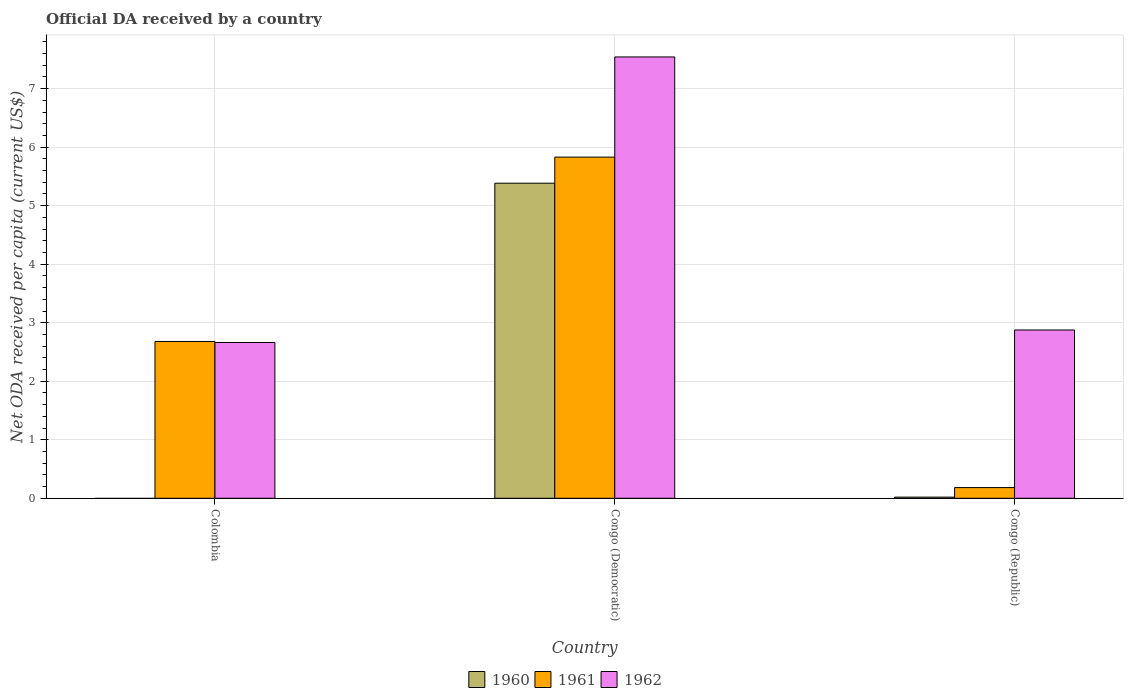How many different coloured bars are there?
Your response must be concise. 3. Are the number of bars per tick equal to the number of legend labels?
Provide a short and direct response. No. Are the number of bars on each tick of the X-axis equal?
Make the answer very short. No. How many bars are there on the 3rd tick from the right?
Make the answer very short. 2. What is the label of the 2nd group of bars from the left?
Ensure brevity in your answer.  Congo (Democratic). In how many cases, is the number of bars for a given country not equal to the number of legend labels?
Ensure brevity in your answer.  1. What is the ODA received in in 1962 in Congo (Democratic)?
Your response must be concise. 7.54. Across all countries, what is the maximum ODA received in in 1961?
Your response must be concise. 5.83. Across all countries, what is the minimum ODA received in in 1962?
Your answer should be very brief. 2.66. In which country was the ODA received in in 1961 maximum?
Offer a terse response. Congo (Democratic). What is the total ODA received in in 1962 in the graph?
Provide a short and direct response. 13.08. What is the difference between the ODA received in in 1962 in Congo (Democratic) and that in Congo (Republic)?
Make the answer very short. 4.67. What is the difference between the ODA received in in 1962 in Colombia and the ODA received in in 1961 in Congo (Democratic)?
Keep it short and to the point. -3.17. What is the average ODA received in in 1961 per country?
Offer a very short reply. 2.9. What is the difference between the ODA received in of/in 1961 and ODA received in of/in 1962 in Colombia?
Offer a terse response. 0.02. What is the ratio of the ODA received in in 1962 in Colombia to that in Congo (Democratic)?
Give a very brief answer. 0.35. Is the ODA received in in 1962 in Colombia less than that in Congo (Republic)?
Ensure brevity in your answer.  Yes. What is the difference between the highest and the second highest ODA received in in 1962?
Keep it short and to the point. 0.21. What is the difference between the highest and the lowest ODA received in in 1960?
Your response must be concise. 5.38. Is it the case that in every country, the sum of the ODA received in in 1962 and ODA received in in 1960 is greater than the ODA received in in 1961?
Your answer should be very brief. No. How many bars are there?
Offer a terse response. 8. Are all the bars in the graph horizontal?
Offer a terse response. No. How many countries are there in the graph?
Offer a very short reply. 3. What is the difference between two consecutive major ticks on the Y-axis?
Make the answer very short. 1. Does the graph contain any zero values?
Give a very brief answer. Yes. Does the graph contain grids?
Provide a short and direct response. Yes. What is the title of the graph?
Provide a short and direct response. Official DA received by a country. What is the label or title of the Y-axis?
Provide a succinct answer. Net ODA received per capita (current US$). What is the Net ODA received per capita (current US$) in 1961 in Colombia?
Provide a short and direct response. 2.68. What is the Net ODA received per capita (current US$) in 1962 in Colombia?
Ensure brevity in your answer.  2.66. What is the Net ODA received per capita (current US$) in 1960 in Congo (Democratic)?
Keep it short and to the point. 5.38. What is the Net ODA received per capita (current US$) of 1961 in Congo (Democratic)?
Provide a succinct answer. 5.83. What is the Net ODA received per capita (current US$) in 1962 in Congo (Democratic)?
Keep it short and to the point. 7.54. What is the Net ODA received per capita (current US$) in 1960 in Congo (Republic)?
Offer a terse response. 0.02. What is the Net ODA received per capita (current US$) of 1961 in Congo (Republic)?
Offer a terse response. 0.18. What is the Net ODA received per capita (current US$) in 1962 in Congo (Republic)?
Ensure brevity in your answer.  2.88. Across all countries, what is the maximum Net ODA received per capita (current US$) of 1960?
Keep it short and to the point. 5.38. Across all countries, what is the maximum Net ODA received per capita (current US$) in 1961?
Your answer should be compact. 5.83. Across all countries, what is the maximum Net ODA received per capita (current US$) of 1962?
Give a very brief answer. 7.54. Across all countries, what is the minimum Net ODA received per capita (current US$) in 1960?
Offer a terse response. 0. Across all countries, what is the minimum Net ODA received per capita (current US$) in 1961?
Give a very brief answer. 0.18. Across all countries, what is the minimum Net ODA received per capita (current US$) of 1962?
Make the answer very short. 2.66. What is the total Net ODA received per capita (current US$) of 1960 in the graph?
Offer a terse response. 5.4. What is the total Net ODA received per capita (current US$) of 1961 in the graph?
Give a very brief answer. 8.69. What is the total Net ODA received per capita (current US$) in 1962 in the graph?
Give a very brief answer. 13.08. What is the difference between the Net ODA received per capita (current US$) of 1961 in Colombia and that in Congo (Democratic)?
Your answer should be very brief. -3.15. What is the difference between the Net ODA received per capita (current US$) in 1962 in Colombia and that in Congo (Democratic)?
Your response must be concise. -4.88. What is the difference between the Net ODA received per capita (current US$) of 1961 in Colombia and that in Congo (Republic)?
Give a very brief answer. 2.5. What is the difference between the Net ODA received per capita (current US$) in 1962 in Colombia and that in Congo (Republic)?
Your response must be concise. -0.21. What is the difference between the Net ODA received per capita (current US$) of 1960 in Congo (Democratic) and that in Congo (Republic)?
Provide a short and direct response. 5.36. What is the difference between the Net ODA received per capita (current US$) of 1961 in Congo (Democratic) and that in Congo (Republic)?
Make the answer very short. 5.65. What is the difference between the Net ODA received per capita (current US$) in 1962 in Congo (Democratic) and that in Congo (Republic)?
Your answer should be compact. 4.67. What is the difference between the Net ODA received per capita (current US$) of 1961 in Colombia and the Net ODA received per capita (current US$) of 1962 in Congo (Democratic)?
Ensure brevity in your answer.  -4.86. What is the difference between the Net ODA received per capita (current US$) in 1961 in Colombia and the Net ODA received per capita (current US$) in 1962 in Congo (Republic)?
Provide a short and direct response. -0.2. What is the difference between the Net ODA received per capita (current US$) of 1960 in Congo (Democratic) and the Net ODA received per capita (current US$) of 1961 in Congo (Republic)?
Provide a succinct answer. 5.2. What is the difference between the Net ODA received per capita (current US$) of 1960 in Congo (Democratic) and the Net ODA received per capita (current US$) of 1962 in Congo (Republic)?
Make the answer very short. 2.51. What is the difference between the Net ODA received per capita (current US$) of 1961 in Congo (Democratic) and the Net ODA received per capita (current US$) of 1962 in Congo (Republic)?
Your answer should be compact. 2.95. What is the average Net ODA received per capita (current US$) of 1960 per country?
Your answer should be very brief. 1.8. What is the average Net ODA received per capita (current US$) in 1961 per country?
Make the answer very short. 2.9. What is the average Net ODA received per capita (current US$) in 1962 per country?
Your answer should be compact. 4.36. What is the difference between the Net ODA received per capita (current US$) in 1961 and Net ODA received per capita (current US$) in 1962 in Colombia?
Your answer should be very brief. 0.02. What is the difference between the Net ODA received per capita (current US$) in 1960 and Net ODA received per capita (current US$) in 1961 in Congo (Democratic)?
Keep it short and to the point. -0.45. What is the difference between the Net ODA received per capita (current US$) in 1960 and Net ODA received per capita (current US$) in 1962 in Congo (Democratic)?
Offer a very short reply. -2.16. What is the difference between the Net ODA received per capita (current US$) of 1961 and Net ODA received per capita (current US$) of 1962 in Congo (Democratic)?
Your answer should be very brief. -1.71. What is the difference between the Net ODA received per capita (current US$) of 1960 and Net ODA received per capita (current US$) of 1961 in Congo (Republic)?
Ensure brevity in your answer.  -0.16. What is the difference between the Net ODA received per capita (current US$) in 1960 and Net ODA received per capita (current US$) in 1962 in Congo (Republic)?
Provide a short and direct response. -2.86. What is the difference between the Net ODA received per capita (current US$) in 1961 and Net ODA received per capita (current US$) in 1962 in Congo (Republic)?
Ensure brevity in your answer.  -2.69. What is the ratio of the Net ODA received per capita (current US$) in 1961 in Colombia to that in Congo (Democratic)?
Offer a terse response. 0.46. What is the ratio of the Net ODA received per capita (current US$) of 1962 in Colombia to that in Congo (Democratic)?
Your response must be concise. 0.35. What is the ratio of the Net ODA received per capita (current US$) of 1961 in Colombia to that in Congo (Republic)?
Your answer should be compact. 14.66. What is the ratio of the Net ODA received per capita (current US$) in 1962 in Colombia to that in Congo (Republic)?
Your answer should be compact. 0.93. What is the ratio of the Net ODA received per capita (current US$) of 1960 in Congo (Democratic) to that in Congo (Republic)?
Give a very brief answer. 272.83. What is the ratio of the Net ODA received per capita (current US$) of 1961 in Congo (Democratic) to that in Congo (Republic)?
Provide a short and direct response. 31.91. What is the ratio of the Net ODA received per capita (current US$) of 1962 in Congo (Democratic) to that in Congo (Republic)?
Offer a terse response. 2.62. What is the difference between the highest and the second highest Net ODA received per capita (current US$) of 1961?
Give a very brief answer. 3.15. What is the difference between the highest and the second highest Net ODA received per capita (current US$) in 1962?
Provide a succinct answer. 4.67. What is the difference between the highest and the lowest Net ODA received per capita (current US$) in 1960?
Provide a succinct answer. 5.38. What is the difference between the highest and the lowest Net ODA received per capita (current US$) in 1961?
Your response must be concise. 5.65. What is the difference between the highest and the lowest Net ODA received per capita (current US$) of 1962?
Offer a terse response. 4.88. 